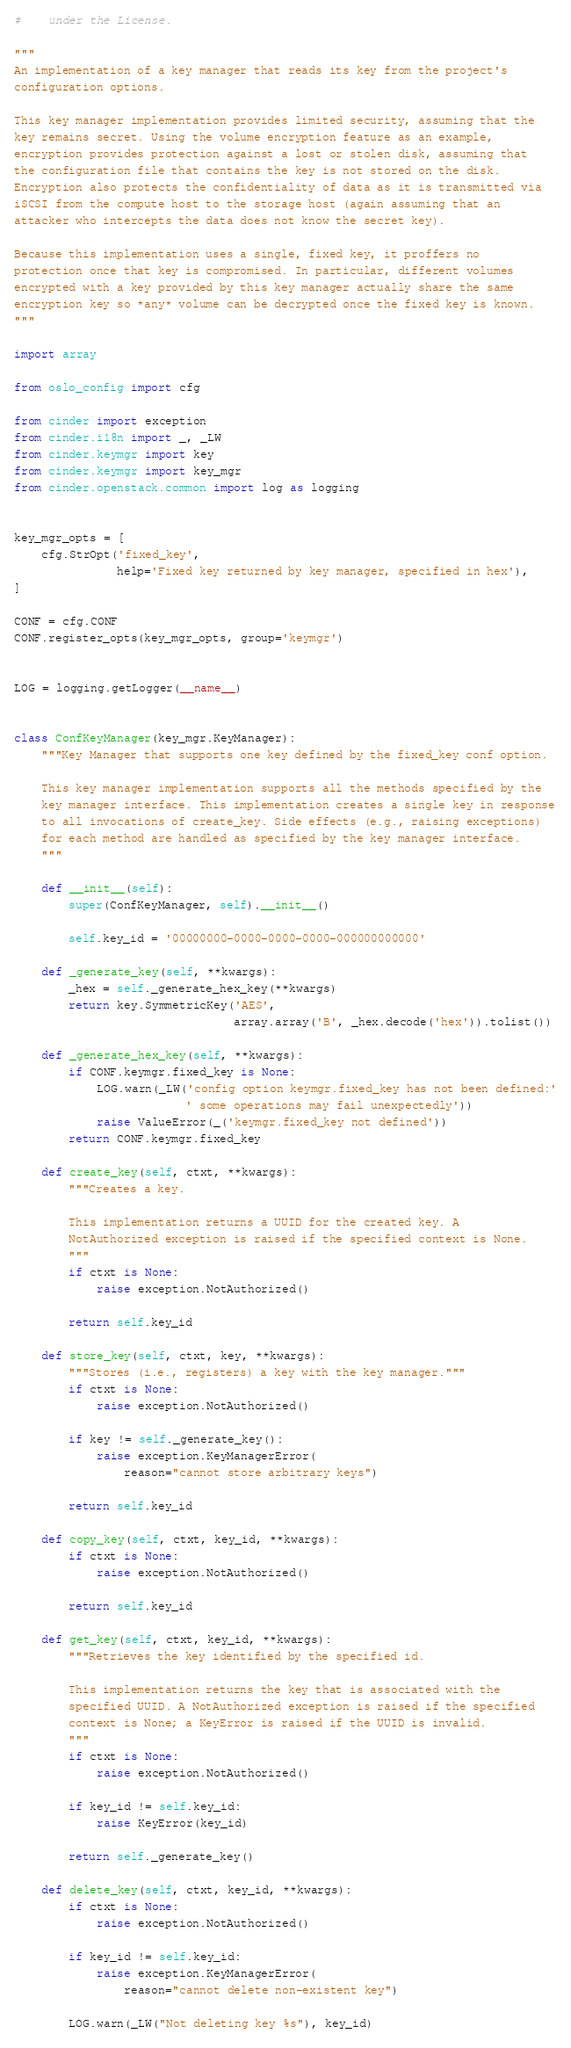<code> <loc_0><loc_0><loc_500><loc_500><_Python_>#    under the License.

"""
An implementation of a key manager that reads its key from the project's
configuration options.

This key manager implementation provides limited security, assuming that the
key remains secret. Using the volume encryption feature as an example,
encryption provides protection against a lost or stolen disk, assuming that
the configuration file that contains the key is not stored on the disk.
Encryption also protects the confidentiality of data as it is transmitted via
iSCSI from the compute host to the storage host (again assuming that an
attacker who intercepts the data does not know the secret key).

Because this implementation uses a single, fixed key, it proffers no
protection once that key is compromised. In particular, different volumes
encrypted with a key provided by this key manager actually share the same
encryption key so *any* volume can be decrypted once the fixed key is known.
"""

import array

from oslo_config import cfg

from cinder import exception
from cinder.i18n import _, _LW
from cinder.keymgr import key
from cinder.keymgr import key_mgr
from cinder.openstack.common import log as logging


key_mgr_opts = [
    cfg.StrOpt('fixed_key',
               help='Fixed key returned by key manager, specified in hex'),
]

CONF = cfg.CONF
CONF.register_opts(key_mgr_opts, group='keymgr')


LOG = logging.getLogger(__name__)


class ConfKeyManager(key_mgr.KeyManager):
    """Key Manager that supports one key defined by the fixed_key conf option.

    This key manager implementation supports all the methods specified by the
    key manager interface. This implementation creates a single key in response
    to all invocations of create_key. Side effects (e.g., raising exceptions)
    for each method are handled as specified by the key manager interface.
    """

    def __init__(self):
        super(ConfKeyManager, self).__init__()

        self.key_id = '00000000-0000-0000-0000-000000000000'

    def _generate_key(self, **kwargs):
        _hex = self._generate_hex_key(**kwargs)
        return key.SymmetricKey('AES',
                                array.array('B', _hex.decode('hex')).tolist())

    def _generate_hex_key(self, **kwargs):
        if CONF.keymgr.fixed_key is None:
            LOG.warn(_LW('config option keymgr.fixed_key has not been defined:'
                         ' some operations may fail unexpectedly'))
            raise ValueError(_('keymgr.fixed_key not defined'))
        return CONF.keymgr.fixed_key

    def create_key(self, ctxt, **kwargs):
        """Creates a key.

        This implementation returns a UUID for the created key. A
        NotAuthorized exception is raised if the specified context is None.
        """
        if ctxt is None:
            raise exception.NotAuthorized()

        return self.key_id

    def store_key(self, ctxt, key, **kwargs):
        """Stores (i.e., registers) a key with the key manager."""
        if ctxt is None:
            raise exception.NotAuthorized()

        if key != self._generate_key():
            raise exception.KeyManagerError(
                reason="cannot store arbitrary keys")

        return self.key_id

    def copy_key(self, ctxt, key_id, **kwargs):
        if ctxt is None:
            raise exception.NotAuthorized()

        return self.key_id

    def get_key(self, ctxt, key_id, **kwargs):
        """Retrieves the key identified by the specified id.

        This implementation returns the key that is associated with the
        specified UUID. A NotAuthorized exception is raised if the specified
        context is None; a KeyError is raised if the UUID is invalid.
        """
        if ctxt is None:
            raise exception.NotAuthorized()

        if key_id != self.key_id:
            raise KeyError(key_id)

        return self._generate_key()

    def delete_key(self, ctxt, key_id, **kwargs):
        if ctxt is None:
            raise exception.NotAuthorized()

        if key_id != self.key_id:
            raise exception.KeyManagerError(
                reason="cannot delete non-existent key")

        LOG.warn(_LW("Not deleting key %s"), key_id)
</code> 